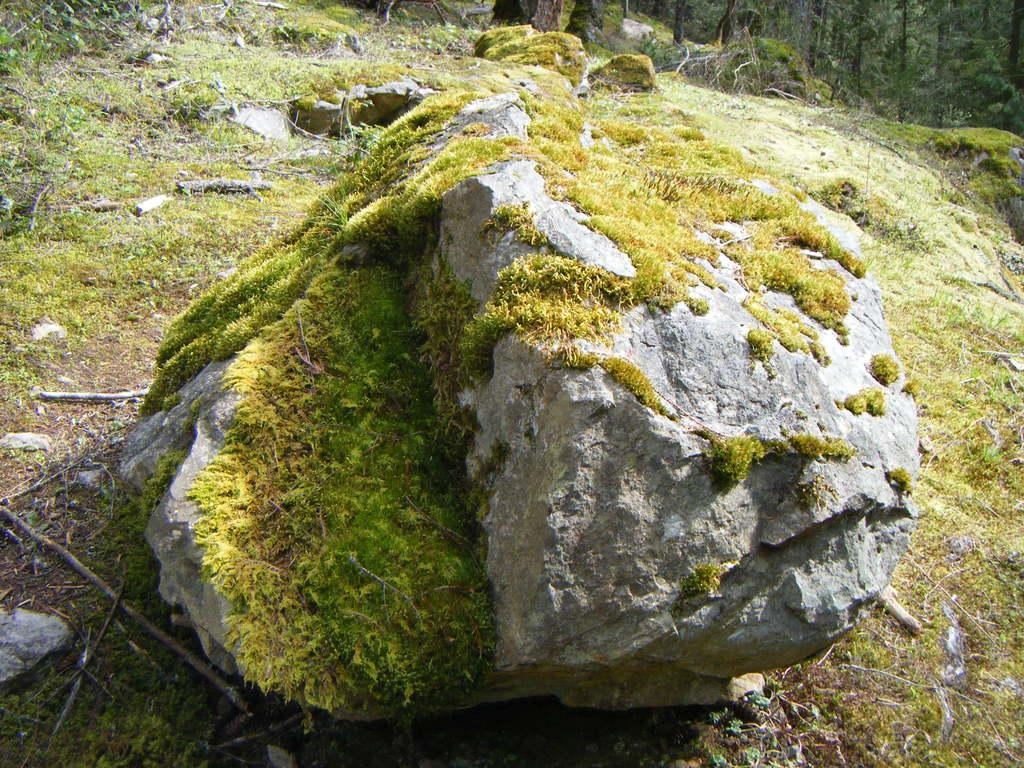What is the main object in the image? There is a rock in the image. What is growing on the rock? There is grass on the rock. What type of vegetation can be seen in the background of the image? There are trees at the back of the image. What can be found on the ground in the image? Dried twigs and leaves are present on the ground. Can you see any blood on the rock in the image? There is no blood present in the image. Is there any smoke coming from the trees in the image? There is no smoke visible in the image. 